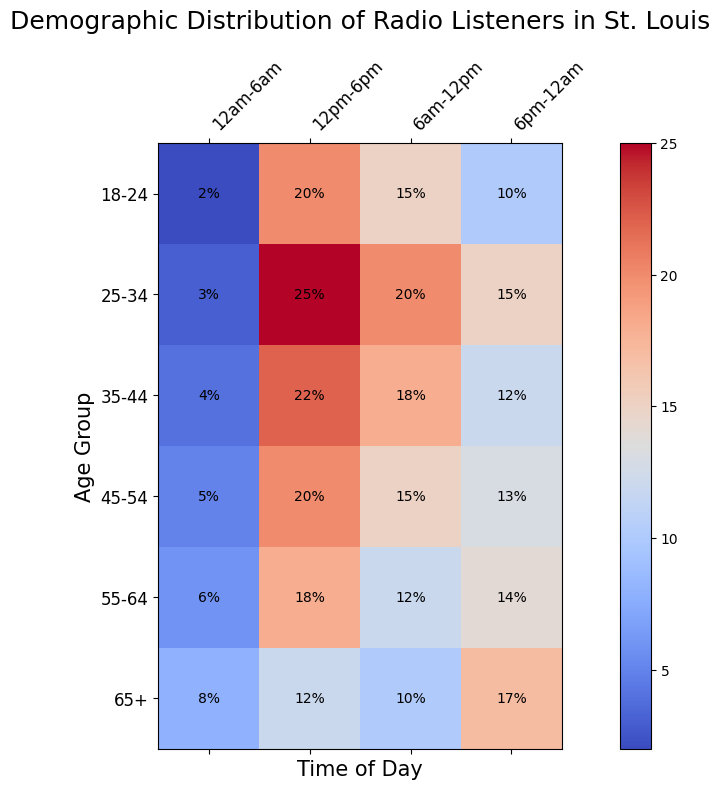What age group has the highest percentage of radio listeners between 12pm and 6pm? To determine this, we look at the cells corresponding to the 12pm-6pm time slot for each age group and find the highest value. The highest value is 25% for the 25-34 age group.
Answer: 25-34 How does the percentage of listeners aged 55-64 differ between the morning (6am-12pm) and evening (6pm-12am) time slots? Refer to the values for the 55-64 age group in the 6am-12pm and 6pm-12am time slots. The morning slot has 12% and the evening slot has 14%. The difference is 14% - 12% = 2%.
Answer: 2% Which time slot has the least listeners for the 18-24 age group, and what is the percentage? Look at the percentage values for each time slot within the 18-24 age group. The least percentage is 2% during the 12am-6am slot.
Answer: 12am-6am, 2% Is there an age group that consistently listens more to the radio during evenings (6pm-12am) compared to mornings (6am-12pm)? Compare the percentages for the 6pm-12am and 6am-12pm slots within each age group. The 65+ age group listens more in the evening (17%) compared to the morning (10%) by a difference of 7%.
Answer: Yes, 65+ What is the average percentage of radio listeners aged 45-54 across all time slots? Add the percentages for each time slot within the 45-54 age group: 5% + 15% + 20% + 13%. Then, divide by the number of time slots (4). The calculation is (5 + 15 + 20 + 13) / 4 = 53 / 4 = 13.25%.
Answer: 13.25% During which time slots does the 35-44 age group have higher percentages of listeners compared to the 55-64 age group? Compare the percentages in each time slot between the 35-44 and 55-64 age groups:
- 12am-6am: 4% (35-44) > 6% (55-64) - No
- 6am-12pm: 18% (35-44) > 12% (55-64) - Yes
- 12pm-6pm: 22% (35-44) > 18% (55-64) - Yes
- 6pm-12am: 12% (35-44) < 14% (55-64) - No
Therefore, the 35-44 age group has higher percentages in the 6am-12pm and 12pm-6pm slots.
Answer: 6am-12pm, 12pm-6pm What is the total percentage of radio listeners aged 18-24 and 35-44 during the afternoon (12pm-6pm) slot? Add the afternoon slot percentages for both age groups: 20% (18-24) + 22% (35-44). The total is 20 + 22 = 42%.
Answer: 42% Which age group shows a peak in their percentage of listeners at midday (6am-12pm), and what is the peak value? Identify the highest percentage in the 6am-12pm slot across all age groups. The highest value is 20% for the 25-34 age group.
Answer: 25-34, 20% How does the listening behavior of the 65+ age group change from the late-night (12am-6am) slot to the evening (6pm-12am) slot in terms of percentage? Compare the 12am-6am and 6pm-12am slots for the 65+ age group. Late-night has 8% and evening has 17%. The change is 17% - 8% = 9%.
Answer: 9% 